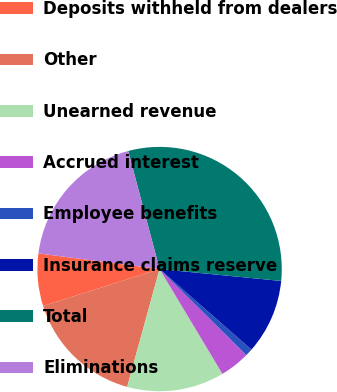Convert chart to OTSL. <chart><loc_0><loc_0><loc_500><loc_500><pie_chart><fcel>Deposits withheld from dealers<fcel>Other<fcel>Unearned revenue<fcel>Accrued interest<fcel>Employee benefits<fcel>Insurance claims reserve<fcel>Total<fcel>Eliminations<nl><fcel>6.93%<fcel>15.84%<fcel>12.87%<fcel>3.96%<fcel>0.99%<fcel>9.9%<fcel>30.69%<fcel>18.81%<nl></chart> 